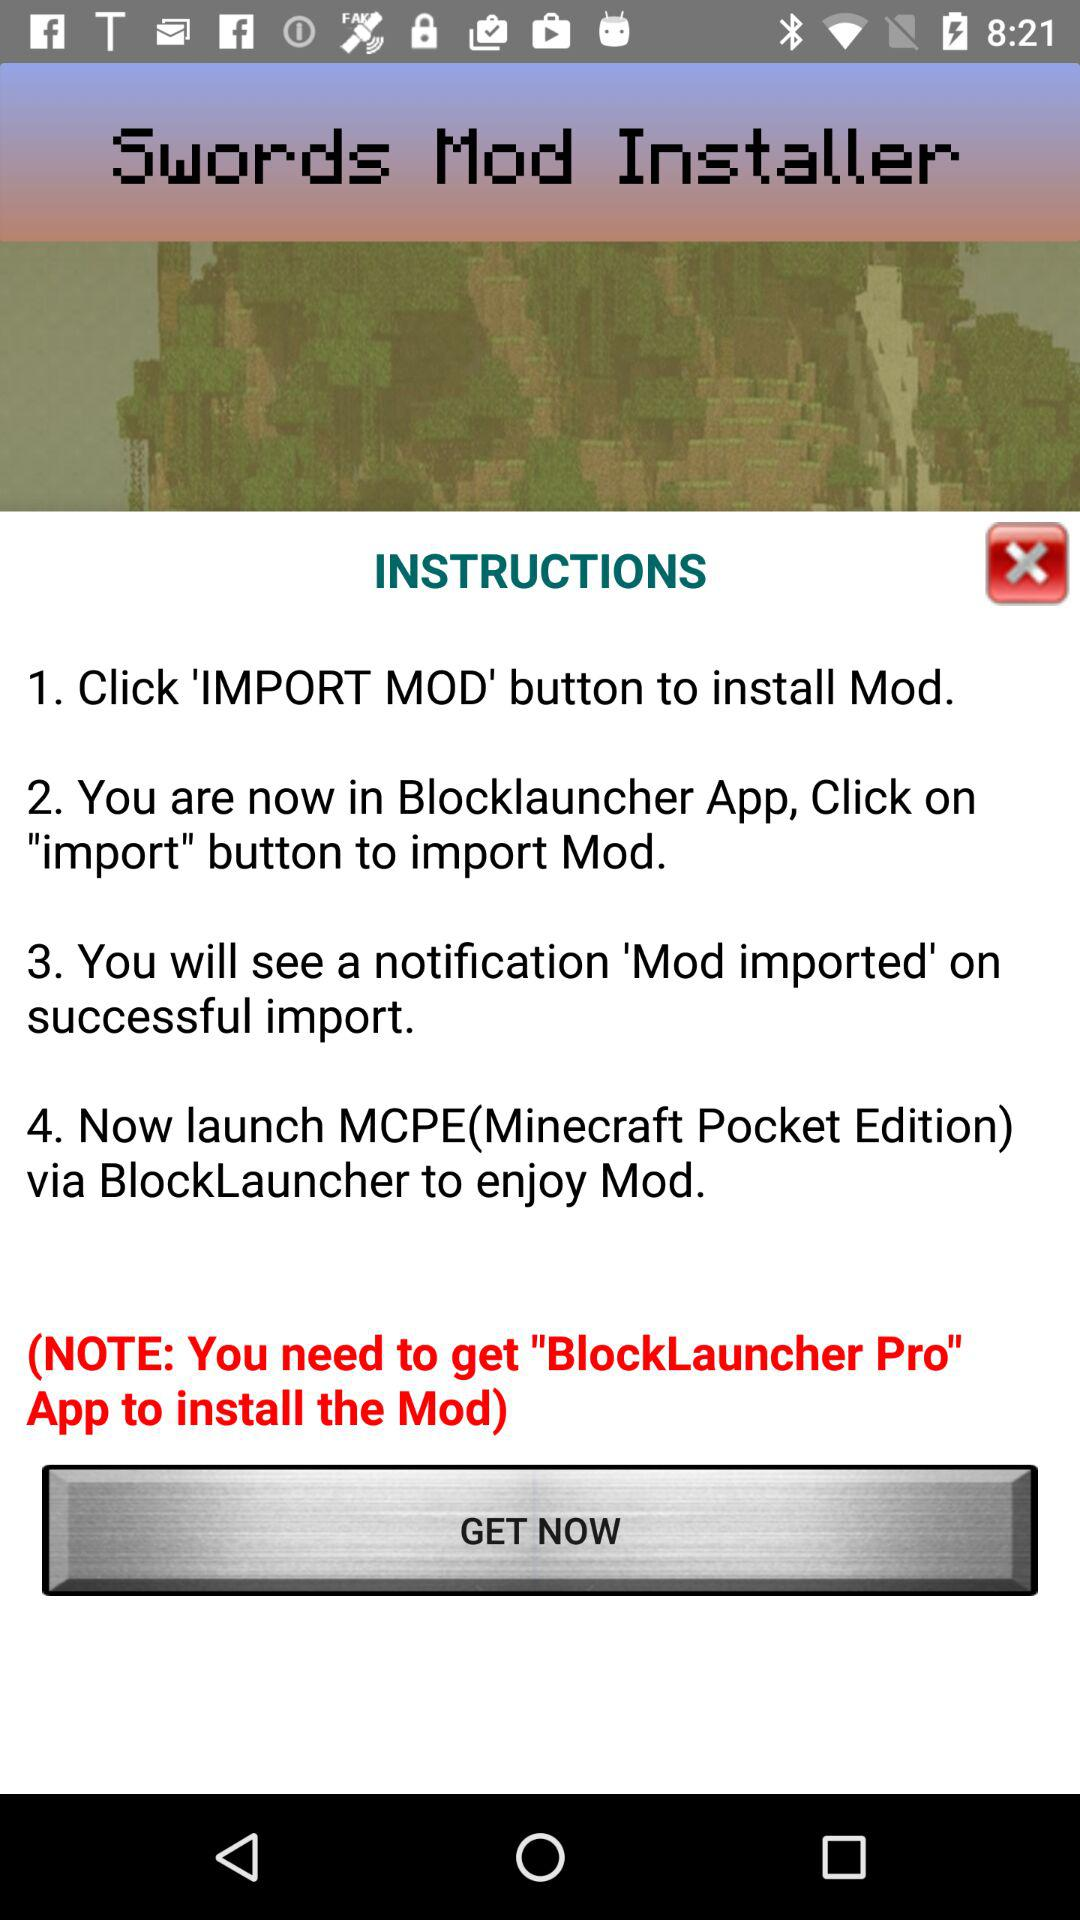Which button should we click to import Mod? You should click the "import" button to import Mod. 